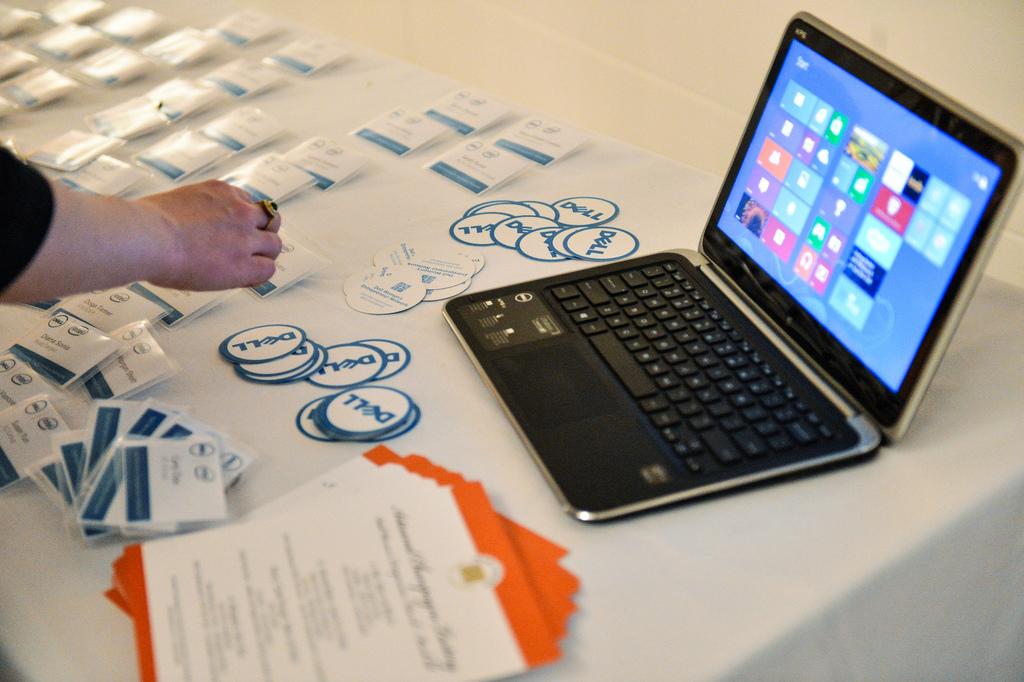Who made those stickers?
Give a very brief answer. Dell. What brand is that computer?
Your answer should be very brief. Dell. 